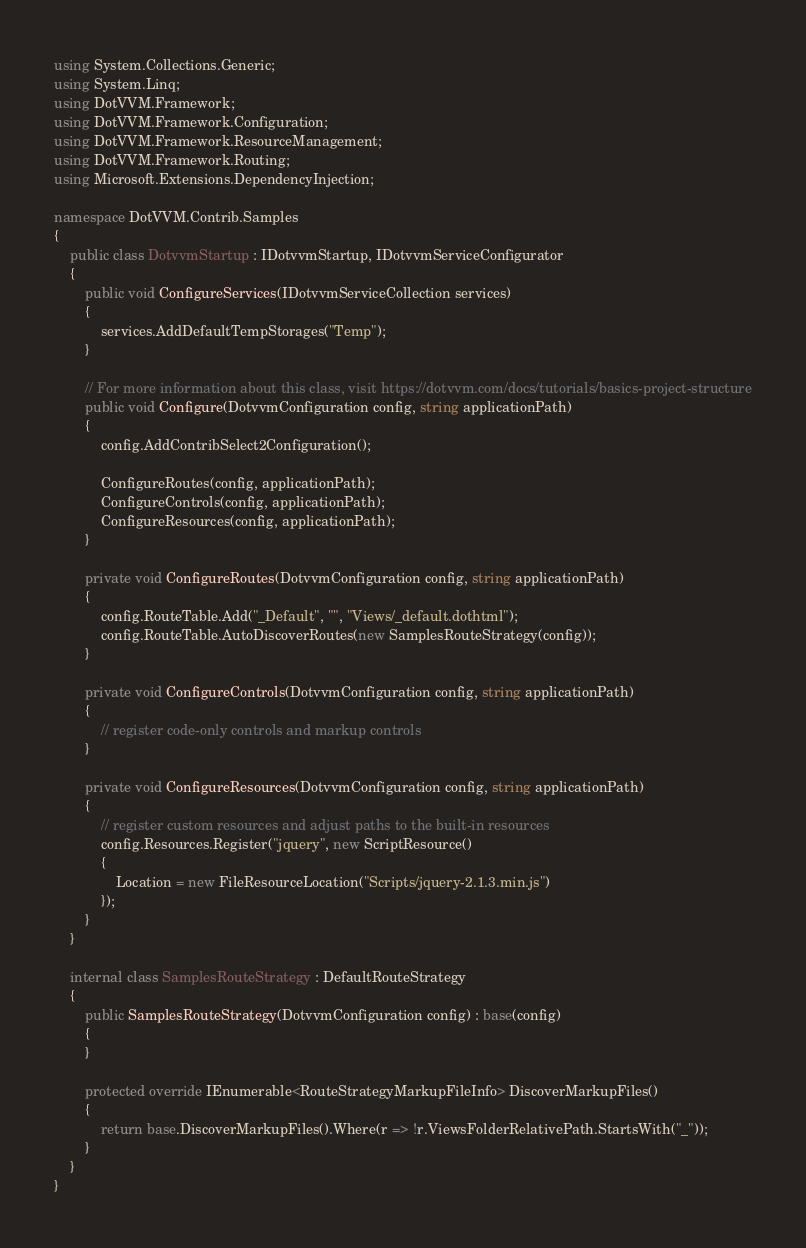Convert code to text. <code><loc_0><loc_0><loc_500><loc_500><_C#_>using System.Collections.Generic;
using System.Linq;
using DotVVM.Framework;
using DotVVM.Framework.Configuration;
using DotVVM.Framework.ResourceManagement;
using DotVVM.Framework.Routing;
using Microsoft.Extensions.DependencyInjection;

namespace DotVVM.Contrib.Samples
{
    public class DotvvmStartup : IDotvvmStartup, IDotvvmServiceConfigurator
    {
        public void ConfigureServices(IDotvvmServiceCollection services)
        {
            services.AddDefaultTempStorages("Temp");
        }

        // For more information about this class, visit https://dotvvm.com/docs/tutorials/basics-project-structure
        public void Configure(DotvvmConfiguration config, string applicationPath)
        {
            config.AddContribSelect2Configuration();

            ConfigureRoutes(config, applicationPath);
            ConfigureControls(config, applicationPath);
            ConfigureResources(config, applicationPath);
        }

        private void ConfigureRoutes(DotvvmConfiguration config, string applicationPath)
        {
            config.RouteTable.Add("_Default", "", "Views/_default.dothtml");
            config.RouteTable.AutoDiscoverRoutes(new SamplesRouteStrategy(config));
        }

        private void ConfigureControls(DotvvmConfiguration config, string applicationPath)
        {
            // register code-only controls and markup controls
        }

        private void ConfigureResources(DotvvmConfiguration config, string applicationPath)
        {
            // register custom resources and adjust paths to the built-in resources
            config.Resources.Register("jquery", new ScriptResource()
            {
                Location = new FileResourceLocation("Scripts/jquery-2.1.3.min.js")
            });
        }
    }

    internal class SamplesRouteStrategy : DefaultRouteStrategy
    {
        public SamplesRouteStrategy(DotvvmConfiguration config) : base(config)
        {
        }

        protected override IEnumerable<RouteStrategyMarkupFileInfo> DiscoverMarkupFiles()
        {
            return base.DiscoverMarkupFiles().Where(r => !r.ViewsFolderRelativePath.StartsWith("_"));
        }
    }
}
</code> 